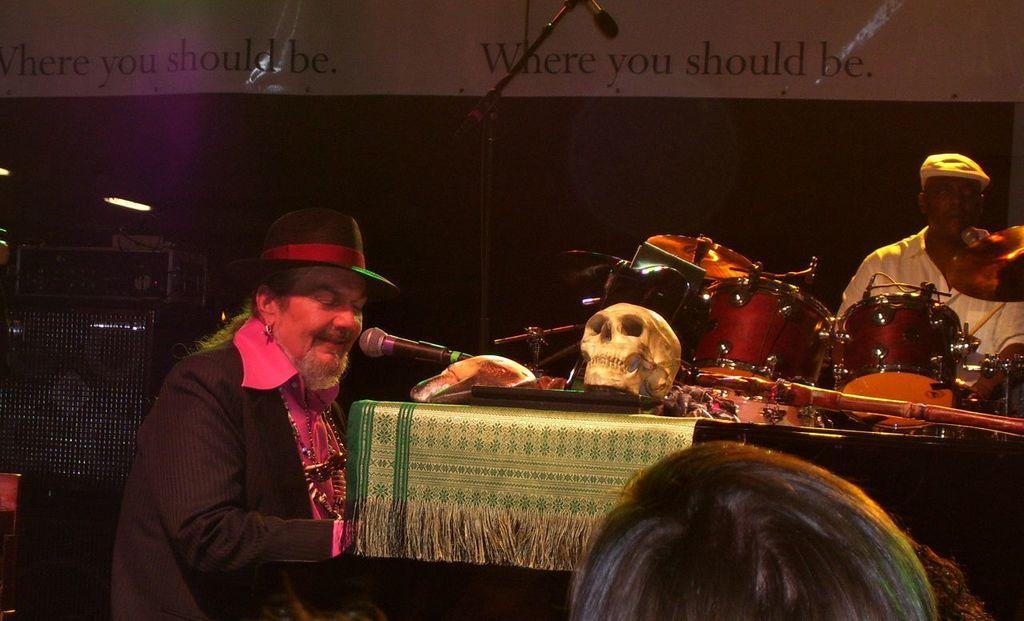Please provide a concise description of this image. In this image i can see two man, the man sitting at the left is singing in front a micro phone and the man sitting at right is playing a musical instrument, at the back ground i can see a banner. 